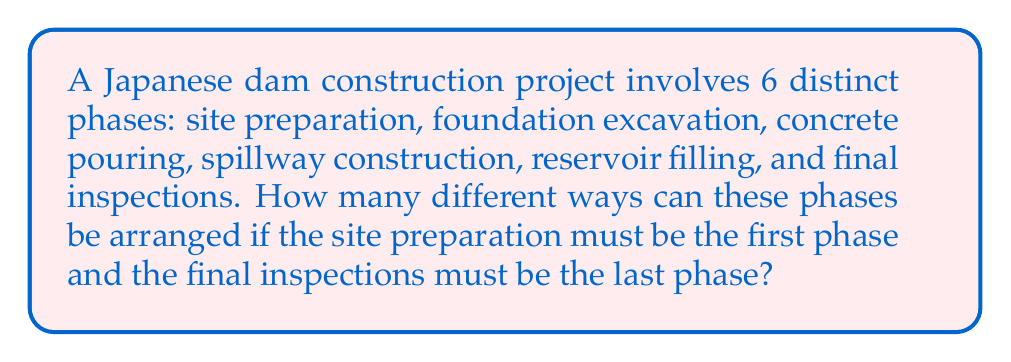Give your solution to this math problem. Let's approach this step-by-step:

1) We have 6 total phases, but two of them (site preparation and final inspections) have fixed positions.

2) This means we only need to arrange the remaining 4 phases (foundation excavation, concrete pouring, spillway construction, and reservoir filling).

3) When we need to arrange all items in a set, we use permutations. The number of permutations of $n$ distinct objects is given by $n!$.

4) In this case, we have 4 phases to arrange, so we're looking for $4!$.

5) Let's calculate this:

   $$4! = 4 \times 3 \times 2 \times 1 = 24$$

Therefore, there are 24 different ways to arrange these construction phases while keeping site preparation first and final inspections last.
Answer: $24$ ways 